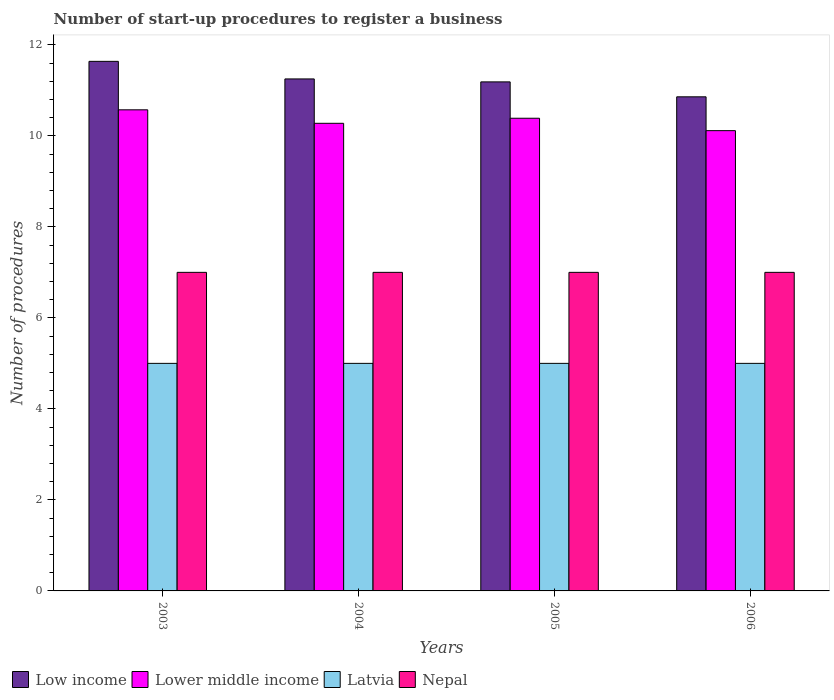How many bars are there on the 3rd tick from the left?
Offer a very short reply. 4. How many bars are there on the 1st tick from the right?
Give a very brief answer. 4. In how many cases, is the number of bars for a given year not equal to the number of legend labels?
Keep it short and to the point. 0. What is the number of procedures required to register a business in Latvia in 2003?
Offer a very short reply. 5. Across all years, what is the maximum number of procedures required to register a business in Latvia?
Offer a terse response. 5. Across all years, what is the minimum number of procedures required to register a business in Low income?
Ensure brevity in your answer.  10.86. In which year was the number of procedures required to register a business in Low income maximum?
Provide a short and direct response. 2003. What is the total number of procedures required to register a business in Lower middle income in the graph?
Ensure brevity in your answer.  41.35. What is the difference between the number of procedures required to register a business in Lower middle income in 2003 and that in 2005?
Provide a short and direct response. 0.19. What is the difference between the number of procedures required to register a business in Nepal in 2003 and the number of procedures required to register a business in Lower middle income in 2004?
Provide a short and direct response. -3.28. What is the average number of procedures required to register a business in Latvia per year?
Keep it short and to the point. 5. In the year 2005, what is the difference between the number of procedures required to register a business in Lower middle income and number of procedures required to register a business in Latvia?
Offer a very short reply. 5.39. What is the ratio of the number of procedures required to register a business in Lower middle income in 2004 to that in 2006?
Offer a very short reply. 1.02. Is the number of procedures required to register a business in Latvia in 2004 less than that in 2005?
Provide a succinct answer. No. What is the difference between the highest and the second highest number of procedures required to register a business in Lower middle income?
Offer a terse response. 0.19. What is the difference between the highest and the lowest number of procedures required to register a business in Low income?
Offer a very short reply. 0.78. In how many years, is the number of procedures required to register a business in Lower middle income greater than the average number of procedures required to register a business in Lower middle income taken over all years?
Offer a terse response. 2. Is it the case that in every year, the sum of the number of procedures required to register a business in Nepal and number of procedures required to register a business in Latvia is greater than the sum of number of procedures required to register a business in Lower middle income and number of procedures required to register a business in Low income?
Give a very brief answer. Yes. What does the 2nd bar from the left in 2005 represents?
Your answer should be compact. Lower middle income. What does the 2nd bar from the right in 2005 represents?
Make the answer very short. Latvia. How many bars are there?
Make the answer very short. 16. Are all the bars in the graph horizontal?
Your response must be concise. No. How many years are there in the graph?
Offer a very short reply. 4. How many legend labels are there?
Your answer should be very brief. 4. What is the title of the graph?
Make the answer very short. Number of start-up procedures to register a business. What is the label or title of the X-axis?
Offer a very short reply. Years. What is the label or title of the Y-axis?
Provide a succinct answer. Number of procedures. What is the Number of procedures of Low income in 2003?
Your response must be concise. 11.64. What is the Number of procedures in Lower middle income in 2003?
Give a very brief answer. 10.57. What is the Number of procedures in Latvia in 2003?
Make the answer very short. 5. What is the Number of procedures in Low income in 2004?
Provide a short and direct response. 11.25. What is the Number of procedures in Lower middle income in 2004?
Offer a terse response. 10.28. What is the Number of procedures in Low income in 2005?
Make the answer very short. 11.19. What is the Number of procedures of Lower middle income in 2005?
Your response must be concise. 10.39. What is the Number of procedures in Latvia in 2005?
Your response must be concise. 5. What is the Number of procedures of Nepal in 2005?
Your response must be concise. 7. What is the Number of procedures in Low income in 2006?
Offer a very short reply. 10.86. What is the Number of procedures of Lower middle income in 2006?
Offer a very short reply. 10.11. What is the Number of procedures of Latvia in 2006?
Offer a terse response. 5. Across all years, what is the maximum Number of procedures in Low income?
Keep it short and to the point. 11.64. Across all years, what is the maximum Number of procedures of Lower middle income?
Make the answer very short. 10.57. Across all years, what is the maximum Number of procedures of Latvia?
Your answer should be compact. 5. Across all years, what is the maximum Number of procedures of Nepal?
Make the answer very short. 7. Across all years, what is the minimum Number of procedures of Low income?
Your answer should be compact. 10.86. Across all years, what is the minimum Number of procedures in Lower middle income?
Keep it short and to the point. 10.11. Across all years, what is the minimum Number of procedures in Latvia?
Your answer should be very brief. 5. Across all years, what is the minimum Number of procedures in Nepal?
Make the answer very short. 7. What is the total Number of procedures of Low income in the graph?
Your answer should be very brief. 44.93. What is the total Number of procedures of Lower middle income in the graph?
Ensure brevity in your answer.  41.35. What is the total Number of procedures of Latvia in the graph?
Provide a succinct answer. 20. What is the difference between the Number of procedures of Low income in 2003 and that in 2004?
Keep it short and to the point. 0.39. What is the difference between the Number of procedures of Lower middle income in 2003 and that in 2004?
Keep it short and to the point. 0.3. What is the difference between the Number of procedures in Latvia in 2003 and that in 2004?
Give a very brief answer. 0. What is the difference between the Number of procedures in Nepal in 2003 and that in 2004?
Offer a very short reply. 0. What is the difference between the Number of procedures in Low income in 2003 and that in 2005?
Provide a succinct answer. 0.45. What is the difference between the Number of procedures in Lower middle income in 2003 and that in 2005?
Keep it short and to the point. 0.19. What is the difference between the Number of procedures of Latvia in 2003 and that in 2005?
Ensure brevity in your answer.  0. What is the difference between the Number of procedures of Low income in 2003 and that in 2006?
Offer a terse response. 0.78. What is the difference between the Number of procedures in Lower middle income in 2003 and that in 2006?
Your response must be concise. 0.46. What is the difference between the Number of procedures in Latvia in 2003 and that in 2006?
Give a very brief answer. 0. What is the difference between the Number of procedures of Low income in 2004 and that in 2005?
Provide a short and direct response. 0.06. What is the difference between the Number of procedures in Lower middle income in 2004 and that in 2005?
Your answer should be compact. -0.11. What is the difference between the Number of procedures of Latvia in 2004 and that in 2005?
Give a very brief answer. 0. What is the difference between the Number of procedures in Nepal in 2004 and that in 2005?
Provide a succinct answer. 0. What is the difference between the Number of procedures in Low income in 2004 and that in 2006?
Offer a terse response. 0.39. What is the difference between the Number of procedures of Lower middle income in 2004 and that in 2006?
Your answer should be compact. 0.16. What is the difference between the Number of procedures of Low income in 2005 and that in 2006?
Make the answer very short. 0.33. What is the difference between the Number of procedures in Lower middle income in 2005 and that in 2006?
Provide a short and direct response. 0.27. What is the difference between the Number of procedures of Nepal in 2005 and that in 2006?
Make the answer very short. 0. What is the difference between the Number of procedures in Low income in 2003 and the Number of procedures in Lower middle income in 2004?
Offer a very short reply. 1.36. What is the difference between the Number of procedures of Low income in 2003 and the Number of procedures of Latvia in 2004?
Offer a very short reply. 6.64. What is the difference between the Number of procedures in Low income in 2003 and the Number of procedures in Nepal in 2004?
Keep it short and to the point. 4.64. What is the difference between the Number of procedures of Lower middle income in 2003 and the Number of procedures of Latvia in 2004?
Your response must be concise. 5.57. What is the difference between the Number of procedures of Lower middle income in 2003 and the Number of procedures of Nepal in 2004?
Give a very brief answer. 3.57. What is the difference between the Number of procedures in Latvia in 2003 and the Number of procedures in Nepal in 2004?
Offer a terse response. -2. What is the difference between the Number of procedures in Low income in 2003 and the Number of procedures in Latvia in 2005?
Ensure brevity in your answer.  6.64. What is the difference between the Number of procedures of Low income in 2003 and the Number of procedures of Nepal in 2005?
Your answer should be compact. 4.64. What is the difference between the Number of procedures in Lower middle income in 2003 and the Number of procedures in Latvia in 2005?
Offer a very short reply. 5.57. What is the difference between the Number of procedures in Lower middle income in 2003 and the Number of procedures in Nepal in 2005?
Your answer should be very brief. 3.57. What is the difference between the Number of procedures of Latvia in 2003 and the Number of procedures of Nepal in 2005?
Give a very brief answer. -2. What is the difference between the Number of procedures in Low income in 2003 and the Number of procedures in Lower middle income in 2006?
Keep it short and to the point. 1.52. What is the difference between the Number of procedures in Low income in 2003 and the Number of procedures in Latvia in 2006?
Your answer should be very brief. 6.64. What is the difference between the Number of procedures of Low income in 2003 and the Number of procedures of Nepal in 2006?
Make the answer very short. 4.64. What is the difference between the Number of procedures in Lower middle income in 2003 and the Number of procedures in Latvia in 2006?
Provide a succinct answer. 5.57. What is the difference between the Number of procedures of Lower middle income in 2003 and the Number of procedures of Nepal in 2006?
Your response must be concise. 3.57. What is the difference between the Number of procedures of Latvia in 2003 and the Number of procedures of Nepal in 2006?
Provide a short and direct response. -2. What is the difference between the Number of procedures of Low income in 2004 and the Number of procedures of Lower middle income in 2005?
Your answer should be very brief. 0.86. What is the difference between the Number of procedures of Low income in 2004 and the Number of procedures of Latvia in 2005?
Offer a terse response. 6.25. What is the difference between the Number of procedures in Low income in 2004 and the Number of procedures in Nepal in 2005?
Ensure brevity in your answer.  4.25. What is the difference between the Number of procedures of Lower middle income in 2004 and the Number of procedures of Latvia in 2005?
Keep it short and to the point. 5.28. What is the difference between the Number of procedures in Lower middle income in 2004 and the Number of procedures in Nepal in 2005?
Your response must be concise. 3.27. What is the difference between the Number of procedures in Latvia in 2004 and the Number of procedures in Nepal in 2005?
Your answer should be very brief. -2. What is the difference between the Number of procedures in Low income in 2004 and the Number of procedures in Lower middle income in 2006?
Offer a very short reply. 1.14. What is the difference between the Number of procedures in Low income in 2004 and the Number of procedures in Latvia in 2006?
Your answer should be very brief. 6.25. What is the difference between the Number of procedures in Low income in 2004 and the Number of procedures in Nepal in 2006?
Offer a very short reply. 4.25. What is the difference between the Number of procedures of Lower middle income in 2004 and the Number of procedures of Latvia in 2006?
Your response must be concise. 5.28. What is the difference between the Number of procedures in Lower middle income in 2004 and the Number of procedures in Nepal in 2006?
Ensure brevity in your answer.  3.27. What is the difference between the Number of procedures in Low income in 2005 and the Number of procedures in Lower middle income in 2006?
Make the answer very short. 1.07. What is the difference between the Number of procedures of Low income in 2005 and the Number of procedures of Latvia in 2006?
Provide a succinct answer. 6.19. What is the difference between the Number of procedures in Low income in 2005 and the Number of procedures in Nepal in 2006?
Your response must be concise. 4.19. What is the difference between the Number of procedures in Lower middle income in 2005 and the Number of procedures in Latvia in 2006?
Offer a terse response. 5.39. What is the difference between the Number of procedures in Lower middle income in 2005 and the Number of procedures in Nepal in 2006?
Give a very brief answer. 3.39. What is the average Number of procedures in Low income per year?
Keep it short and to the point. 11.23. What is the average Number of procedures of Lower middle income per year?
Make the answer very short. 10.34. What is the average Number of procedures of Nepal per year?
Ensure brevity in your answer.  7. In the year 2003, what is the difference between the Number of procedures of Low income and Number of procedures of Lower middle income?
Keep it short and to the point. 1.06. In the year 2003, what is the difference between the Number of procedures in Low income and Number of procedures in Latvia?
Make the answer very short. 6.64. In the year 2003, what is the difference between the Number of procedures of Low income and Number of procedures of Nepal?
Offer a terse response. 4.64. In the year 2003, what is the difference between the Number of procedures in Lower middle income and Number of procedures in Latvia?
Offer a very short reply. 5.57. In the year 2003, what is the difference between the Number of procedures in Lower middle income and Number of procedures in Nepal?
Your answer should be very brief. 3.57. In the year 2003, what is the difference between the Number of procedures of Latvia and Number of procedures of Nepal?
Your response must be concise. -2. In the year 2004, what is the difference between the Number of procedures in Low income and Number of procedures in Latvia?
Your answer should be very brief. 6.25. In the year 2004, what is the difference between the Number of procedures in Low income and Number of procedures in Nepal?
Your answer should be compact. 4.25. In the year 2004, what is the difference between the Number of procedures in Lower middle income and Number of procedures in Latvia?
Your response must be concise. 5.28. In the year 2004, what is the difference between the Number of procedures of Lower middle income and Number of procedures of Nepal?
Your answer should be compact. 3.27. In the year 2005, what is the difference between the Number of procedures of Low income and Number of procedures of Lower middle income?
Give a very brief answer. 0.8. In the year 2005, what is the difference between the Number of procedures of Low income and Number of procedures of Latvia?
Make the answer very short. 6.19. In the year 2005, what is the difference between the Number of procedures of Low income and Number of procedures of Nepal?
Your answer should be very brief. 4.19. In the year 2005, what is the difference between the Number of procedures of Lower middle income and Number of procedures of Latvia?
Make the answer very short. 5.39. In the year 2005, what is the difference between the Number of procedures of Lower middle income and Number of procedures of Nepal?
Offer a terse response. 3.39. In the year 2006, what is the difference between the Number of procedures in Low income and Number of procedures in Lower middle income?
Provide a succinct answer. 0.74. In the year 2006, what is the difference between the Number of procedures in Low income and Number of procedures in Latvia?
Give a very brief answer. 5.86. In the year 2006, what is the difference between the Number of procedures of Low income and Number of procedures of Nepal?
Give a very brief answer. 3.86. In the year 2006, what is the difference between the Number of procedures in Lower middle income and Number of procedures in Latvia?
Ensure brevity in your answer.  5.11. In the year 2006, what is the difference between the Number of procedures in Lower middle income and Number of procedures in Nepal?
Keep it short and to the point. 3.11. In the year 2006, what is the difference between the Number of procedures of Latvia and Number of procedures of Nepal?
Provide a short and direct response. -2. What is the ratio of the Number of procedures of Low income in 2003 to that in 2004?
Your answer should be compact. 1.03. What is the ratio of the Number of procedures in Lower middle income in 2003 to that in 2004?
Keep it short and to the point. 1.03. What is the ratio of the Number of procedures in Nepal in 2003 to that in 2004?
Ensure brevity in your answer.  1. What is the ratio of the Number of procedures of Low income in 2003 to that in 2005?
Your answer should be compact. 1.04. What is the ratio of the Number of procedures of Lower middle income in 2003 to that in 2005?
Your response must be concise. 1.02. What is the ratio of the Number of procedures of Latvia in 2003 to that in 2005?
Your response must be concise. 1. What is the ratio of the Number of procedures in Nepal in 2003 to that in 2005?
Ensure brevity in your answer.  1. What is the ratio of the Number of procedures in Low income in 2003 to that in 2006?
Keep it short and to the point. 1.07. What is the ratio of the Number of procedures in Lower middle income in 2003 to that in 2006?
Your response must be concise. 1.05. What is the ratio of the Number of procedures in Nepal in 2003 to that in 2006?
Offer a terse response. 1. What is the ratio of the Number of procedures in Lower middle income in 2004 to that in 2005?
Keep it short and to the point. 0.99. What is the ratio of the Number of procedures of Nepal in 2004 to that in 2005?
Provide a succinct answer. 1. What is the ratio of the Number of procedures in Low income in 2004 to that in 2006?
Provide a succinct answer. 1.04. What is the ratio of the Number of procedures of Lower middle income in 2004 to that in 2006?
Ensure brevity in your answer.  1.02. What is the ratio of the Number of procedures of Latvia in 2004 to that in 2006?
Make the answer very short. 1. What is the ratio of the Number of procedures of Nepal in 2004 to that in 2006?
Your answer should be very brief. 1. What is the ratio of the Number of procedures in Low income in 2005 to that in 2006?
Offer a terse response. 1.03. What is the ratio of the Number of procedures of Nepal in 2005 to that in 2006?
Keep it short and to the point. 1. What is the difference between the highest and the second highest Number of procedures in Low income?
Your answer should be compact. 0.39. What is the difference between the highest and the second highest Number of procedures of Lower middle income?
Keep it short and to the point. 0.19. What is the difference between the highest and the lowest Number of procedures in Low income?
Your answer should be very brief. 0.78. What is the difference between the highest and the lowest Number of procedures of Lower middle income?
Offer a very short reply. 0.46. 